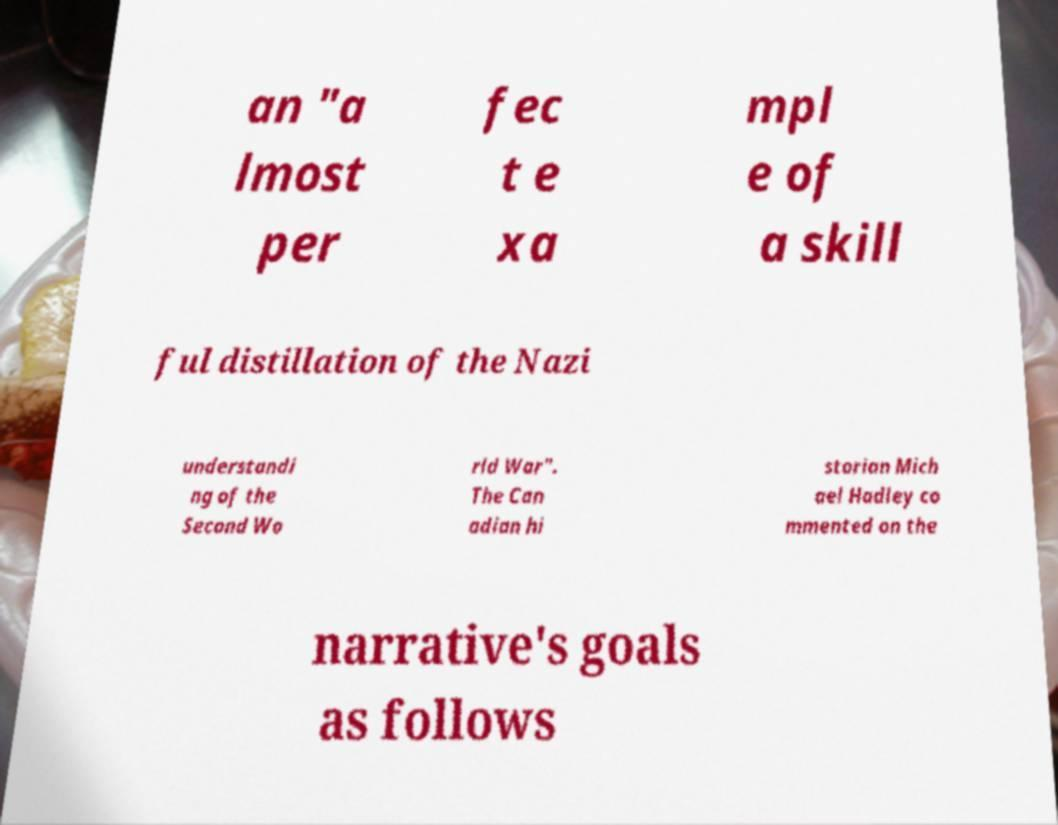Could you assist in decoding the text presented in this image and type it out clearly? an "a lmost per fec t e xa mpl e of a skill ful distillation of the Nazi understandi ng of the Second Wo rld War". The Can adian hi storian Mich ael Hadley co mmented on the narrative's goals as follows 